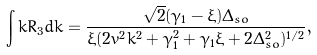<formula> <loc_0><loc_0><loc_500><loc_500>\int k R _ { 3 } d k = \frac { \sqrt { 2 } ( \gamma _ { 1 } - \xi ) \Delta _ { s o } } { \xi ( 2 v ^ { 2 } k ^ { 2 } + \gamma _ { 1 } ^ { 2 } + \gamma _ { 1 } \xi + 2 \Delta _ { s o } ^ { 2 } ) ^ { 1 / 2 } } ,</formula> 